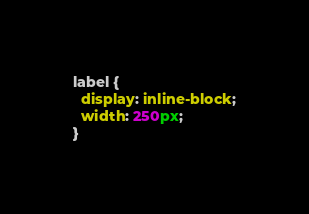<code> <loc_0><loc_0><loc_500><loc_500><_CSS_>label {
  display: inline-block;
  width: 250px;
}</code> 